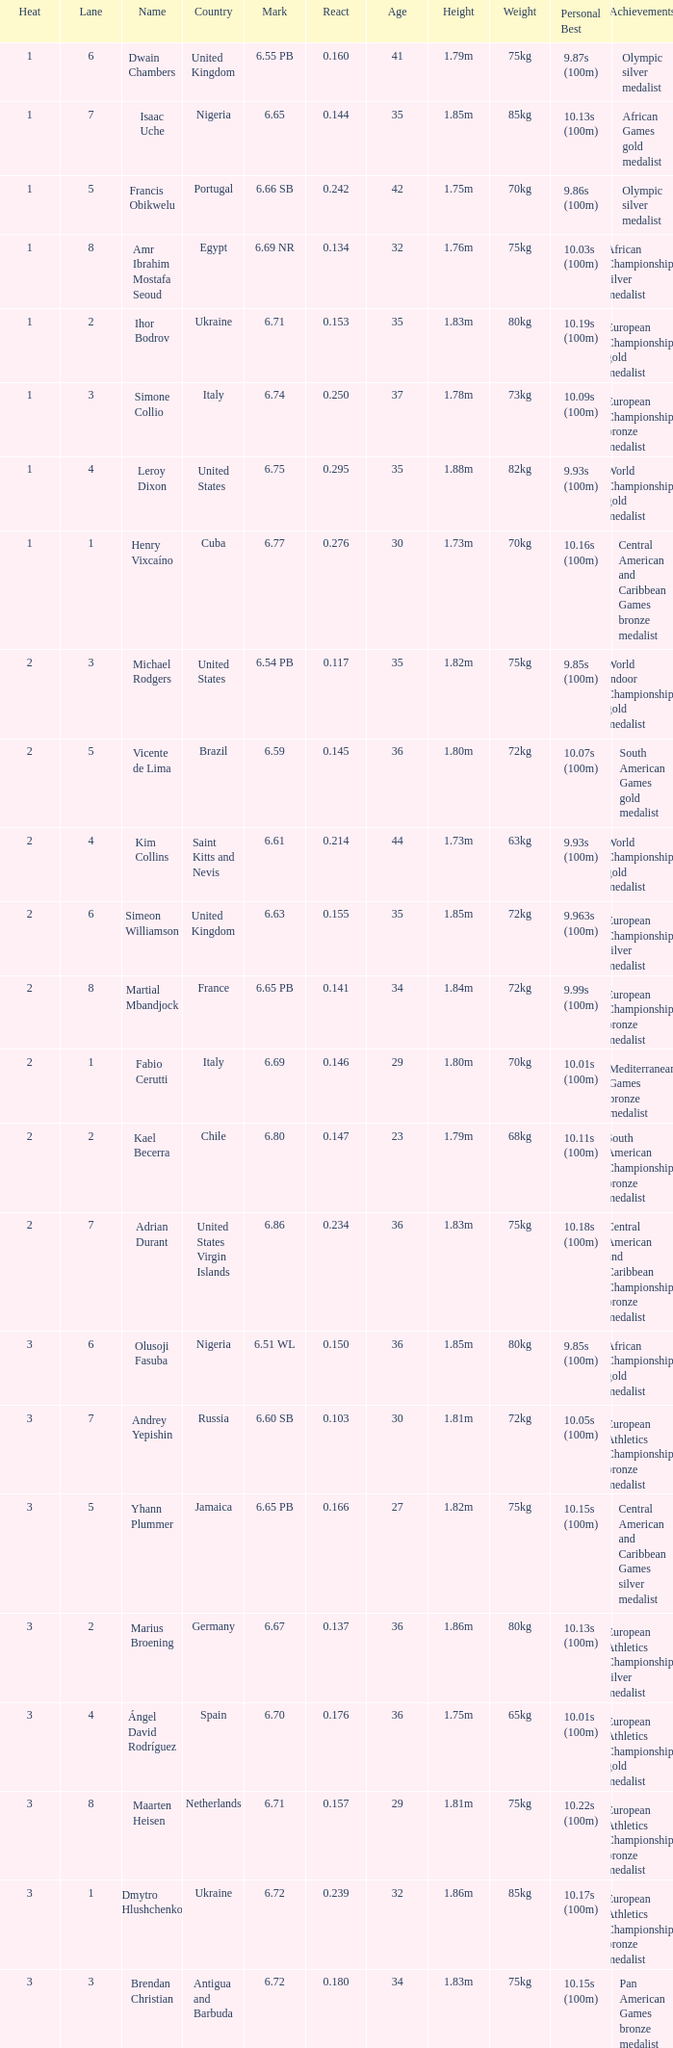Can you give me this table as a dict? {'header': ['Heat', 'Lane', 'Name', 'Country', 'Mark', 'React', 'Age', 'Height', 'Weight', 'Personal Best', 'Achievements'], 'rows': [['1', '6', 'Dwain Chambers', 'United Kingdom', '6.55 PB', '0.160', '41', '1.79m', '75kg', '9.87s (100m)', 'Olympic silver medalist'], ['1', '7', 'Isaac Uche', 'Nigeria', '6.65', '0.144', '35', '1.85m', '85kg', '10.13s (100m)', 'African Games gold medalist'], ['1', '5', 'Francis Obikwelu', 'Portugal', '6.66 SB', '0.242', '42', '1.75m', '70kg', '9.86s (100m)', 'Olympic silver medalist'], ['1', '8', 'Amr Ibrahim Mostafa Seoud', 'Egypt', '6.69 NR', '0.134', '32', '1.76m', '75kg', '10.03s (100m)', 'African Championships silver medalist'], ['1', '2', 'Ihor Bodrov', 'Ukraine', '6.71', '0.153', '35', '1.83m', '80kg', '10.19s (100m)', 'European Championships gold medalist'], ['1', '3', 'Simone Collio', 'Italy', '6.74', '0.250', '37', '1.78m', '73kg', '10.09s (100m)', 'European Championships bronze medalist'], ['1', '4', 'Leroy Dixon', 'United States', '6.75', '0.295', '35', '1.88m', '82kg', '9.93s (100m)', 'World Championships gold medalist'], ['1', '1', 'Henry Vixcaíno', 'Cuba', '6.77', '0.276', '30', '1.73m', '70kg', '10.16s (100m)', 'Central American and Caribbean Games bronze medalist'], ['2', '3', 'Michael Rodgers', 'United States', '6.54 PB', '0.117', '35', '1.82m', '75kg', '9.85s (100m)', 'World Indoor Championships gold medalist'], ['2', '5', 'Vicente de Lima', 'Brazil', '6.59', '0.145', '36', '1.80m', '72kg', '10.07s (100m)', 'South American Games gold medalist'], ['2', '4', 'Kim Collins', 'Saint Kitts and Nevis', '6.61', '0.214', '44', '1.73m', '63kg', '9.93s (100m)', 'World Championships gold medalist'], ['2', '6', 'Simeon Williamson', 'United Kingdom', '6.63', '0.155', '35', '1.85m', '72kg', '9.963s (100m)', 'European Championships silver medalist'], ['2', '8', 'Martial Mbandjock', 'France', '6.65 PB', '0.141', '34', '1.84m', '72kg', '9.99s (100m)', 'European Championships bronze medalist'], ['2', '1', 'Fabio Cerutti', 'Italy', '6.69', '0.146', '29', '1.80m', '70kg', '10.01s (100m)', 'Mediterranean Games bronze medalist'], ['2', '2', 'Kael Becerra', 'Chile', '6.80', '0.147', '23', '1.79m', '68kg', '10.11s (100m)', 'South American Championships bronze medalist'], ['2', '7', 'Adrian Durant', 'United States Virgin Islands', '6.86', '0.234', '36', '1.83m', '75kg', '10.18s (100m)', 'Central American and Caribbean Championships bronze medalist'], ['3', '6', 'Olusoji Fasuba', 'Nigeria', '6.51 WL', '0.150', '36', '1.85m', '80kg', '9.85s (100m)', 'African Championships gold medalist'], ['3', '7', 'Andrey Yepishin', 'Russia', '6.60 SB', '0.103', '30', '1.81m', '72kg', '10.05s (100m)', 'European Athletics Championships bronze medalist'], ['3', '5', 'Yhann Plummer', 'Jamaica', '6.65 PB', '0.166', '27', '1.82m', '75kg', '10.15s (100m)', 'Central American and Caribbean Games silver medalist'], ['3', '2', 'Marius Broening', 'Germany', '6.67', '0.137', '36', '1.86m', '80kg', '10.13s (100m)', 'European Athletics Championships silver medalist'], ['3', '4', 'Ángel David Rodríguez', 'Spain', '6.70', '0.176', '36', '1.75m', '65kg', '10.01s (100m)', 'European Athletics Championships gold medalist'], ['3', '8', 'Maarten Heisen', 'Netherlands', '6.71', '0.157', '29', '1.81m', '75kg', '10.22s (100m)', 'European Athletics Championships bronze medalist'], ['3', '1', 'Dmytro Hlushchenko', 'Ukraine', '6.72', '0.239', '32', '1.86m', '85kg', '10.17s (100m)', 'European Athletics Championships bronze medalist'], ['3', '3', 'Brendan Christian', 'Antigua and Barbuda', '6.72', '0.180', '34', '1.83m', '75kg', '10.15s (100m)', 'Pan American Games bronze medalist']]} What is Country, when Lane is 5, and when React is greater than 0.166? Portugal. 